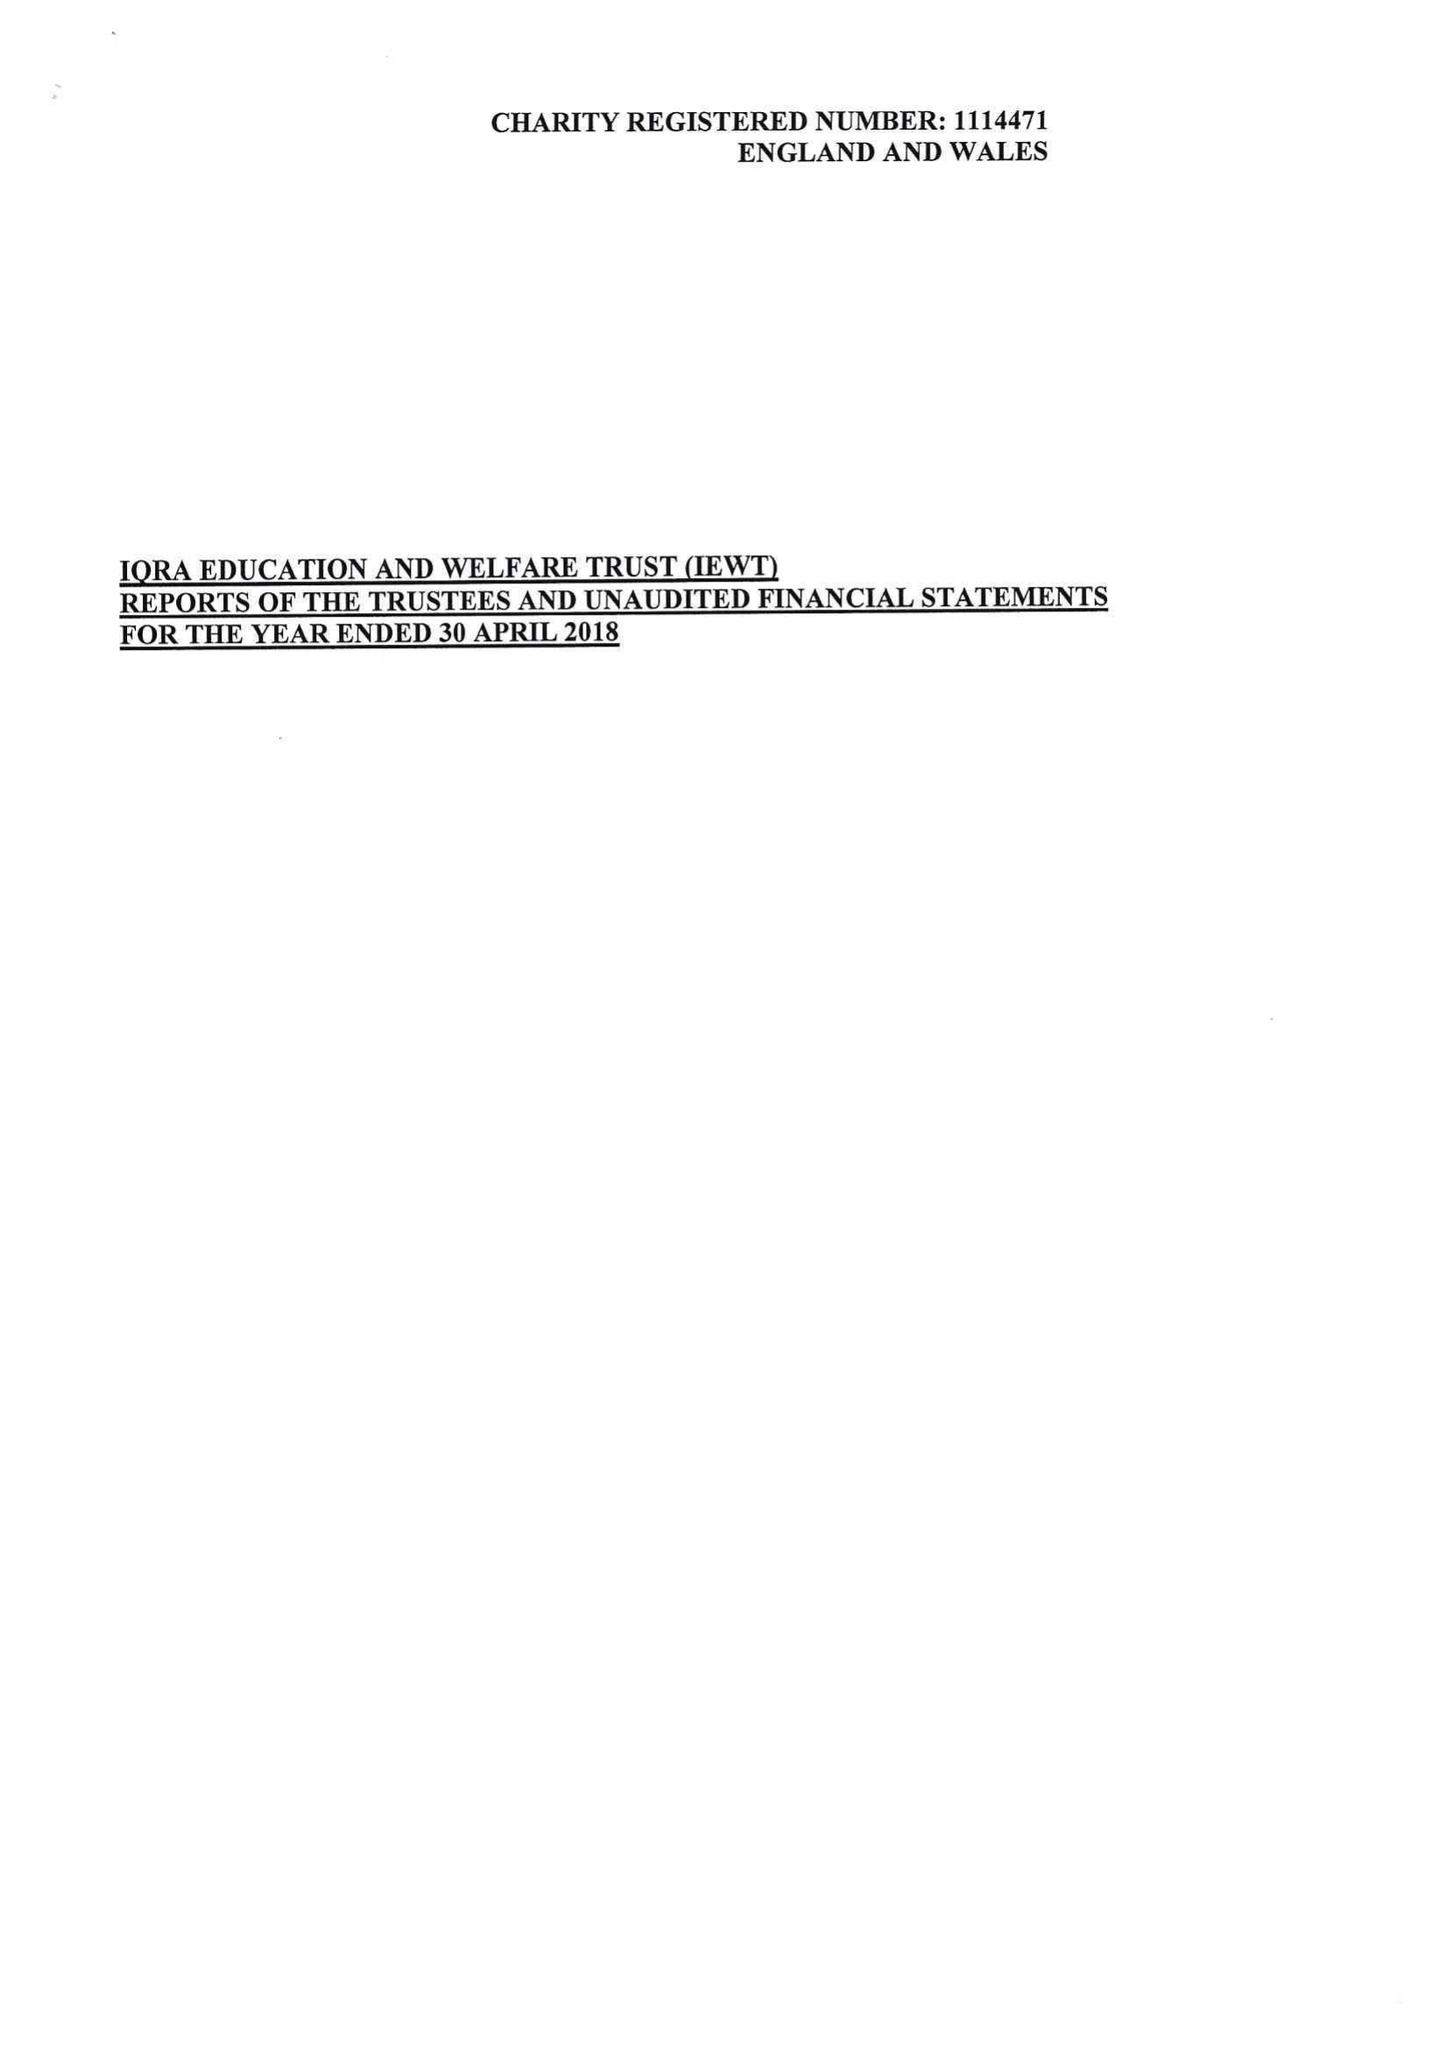What is the value for the report_date?
Answer the question using a single word or phrase. 2018-04-30 